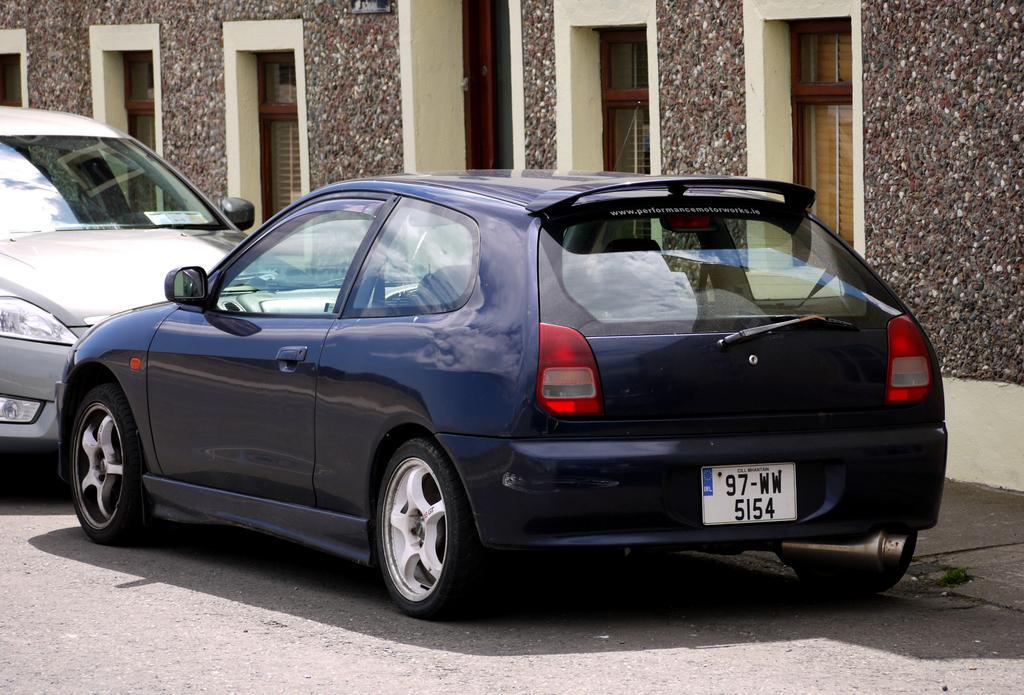Please provide a concise description of this image. In this image we can see two cars parked on the road. Behind the cars there is a building with windows. 